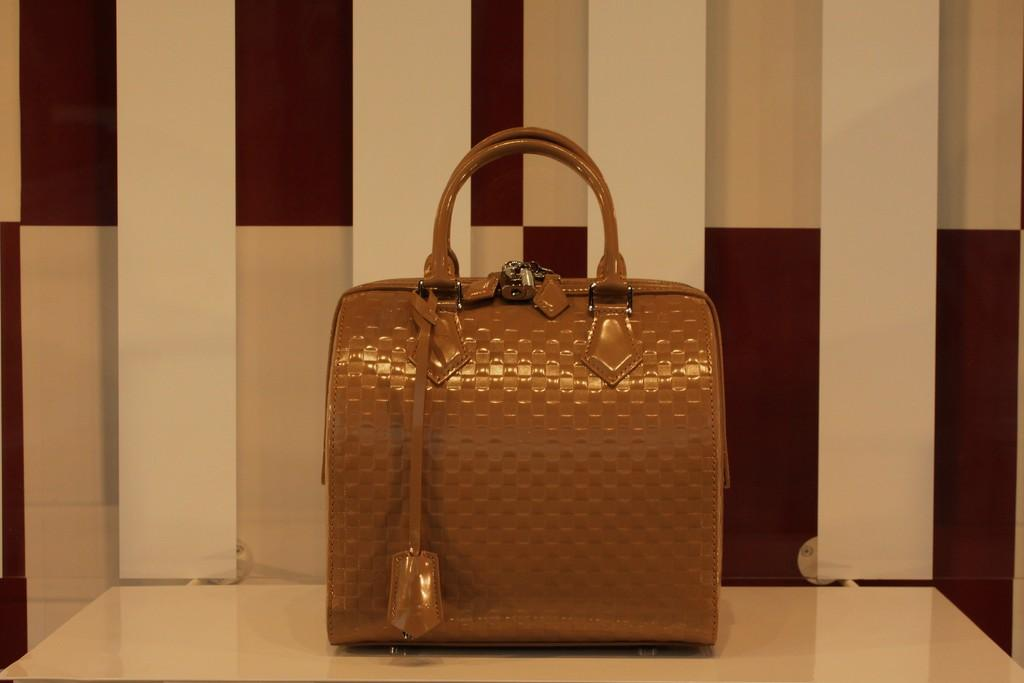What is placed on the table in the image? There is a brown color bag on the table. What can be seen behind the bag on the table? There is a wall visible behind the bag. Can you describe the wall's appearance? The wall has red and cream color tiles. How many babies are crawling on the sheet in the image? There are no babies or sheets present in the image. 